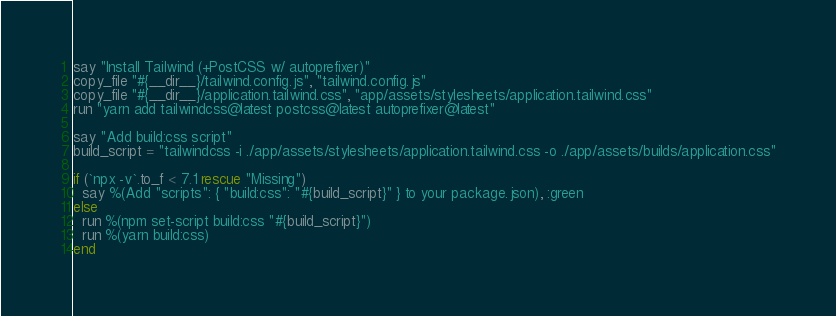Convert code to text. <code><loc_0><loc_0><loc_500><loc_500><_Ruby_>say "Install Tailwind (+PostCSS w/ autoprefixer)"
copy_file "#{__dir__}/tailwind.config.js", "tailwind.config.js"
copy_file "#{__dir__}/application.tailwind.css", "app/assets/stylesheets/application.tailwind.css"
run "yarn add tailwindcss@latest postcss@latest autoprefixer@latest"

say "Add build:css script"
build_script = "tailwindcss -i ./app/assets/stylesheets/application.tailwind.css -o ./app/assets/builds/application.css"

if (`npx -v`.to_f < 7.1 rescue "Missing")
  say %(Add "scripts": { "build:css": "#{build_script}" } to your package.json), :green
else
  run %(npm set-script build:css "#{build_script}")
  run %(yarn build:css)
end
</code> 